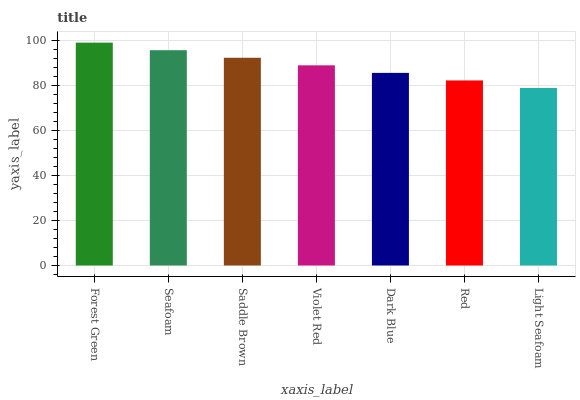Is Seafoam the minimum?
Answer yes or no. No. Is Seafoam the maximum?
Answer yes or no. No. Is Forest Green greater than Seafoam?
Answer yes or no. Yes. Is Seafoam less than Forest Green?
Answer yes or no. Yes. Is Seafoam greater than Forest Green?
Answer yes or no. No. Is Forest Green less than Seafoam?
Answer yes or no. No. Is Violet Red the high median?
Answer yes or no. Yes. Is Violet Red the low median?
Answer yes or no. Yes. Is Red the high median?
Answer yes or no. No. Is Light Seafoam the low median?
Answer yes or no. No. 